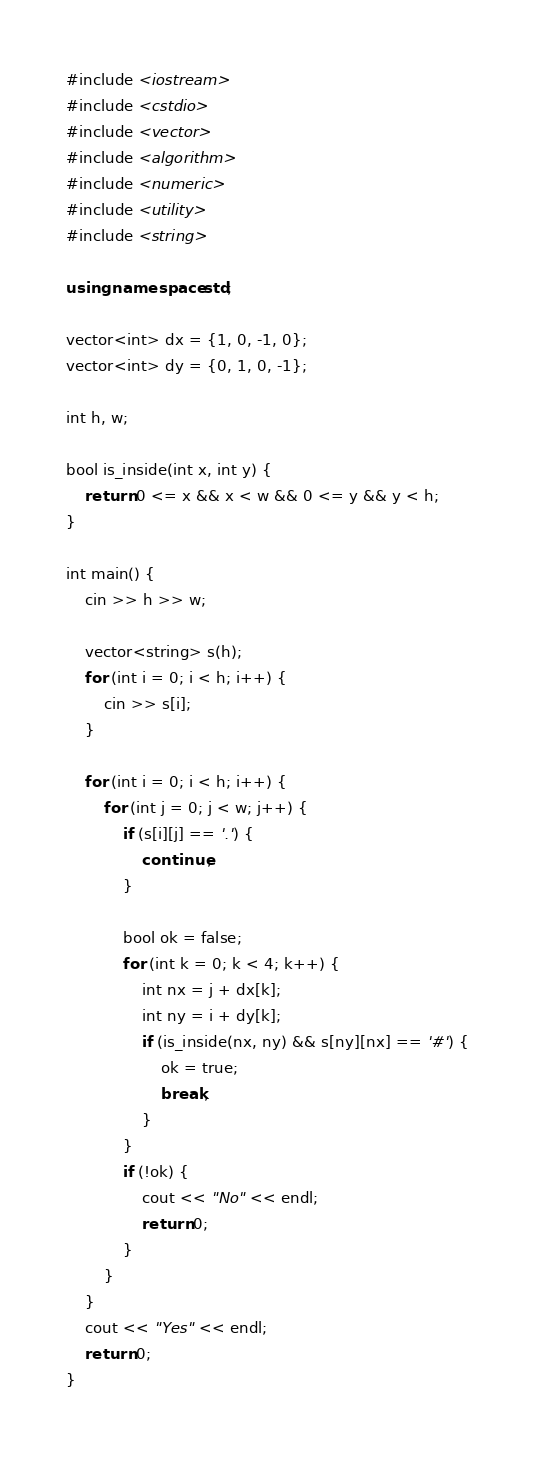<code> <loc_0><loc_0><loc_500><loc_500><_C++_>#include <iostream>
#include <cstdio>
#include <vector>
#include <algorithm>
#include <numeric>
#include <utility>
#include <string>

using namespace std;

vector<int> dx = {1, 0, -1, 0};
vector<int> dy = {0, 1, 0, -1};

int h, w;

bool is_inside(int x, int y) {
	return 0 <= x && x < w && 0 <= y && y < h;
}

int main() {
	cin >> h >> w;

	vector<string> s(h);
	for (int i = 0; i < h; i++) {
		cin >> s[i];
	}

	for (int i = 0; i < h; i++) {
		for (int j = 0; j < w; j++) {
			if (s[i][j] == '.') {
				continue;
			}

			bool ok = false;
			for (int k = 0; k < 4; k++) {
				int nx = j + dx[k];
				int ny = i + dy[k];
				if (is_inside(nx, ny) && s[ny][nx] == '#') {
					ok = true;
					break;
				}
			}
			if (!ok) {
				cout << "No" << endl;
				return 0;
			}
		}
	}
	cout << "Yes" << endl;
	return 0;
}
</code> 